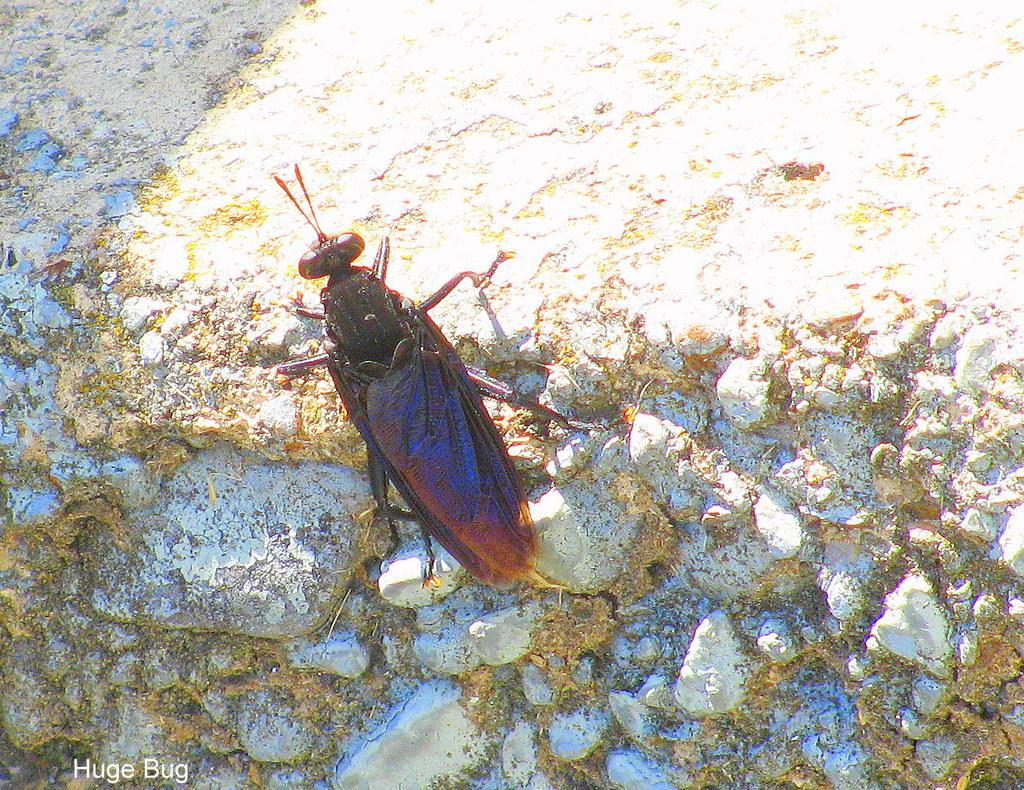Please provide a concise description of this image. In this image I can see an insect on the rock. I can see an insect is in black and brown color. 